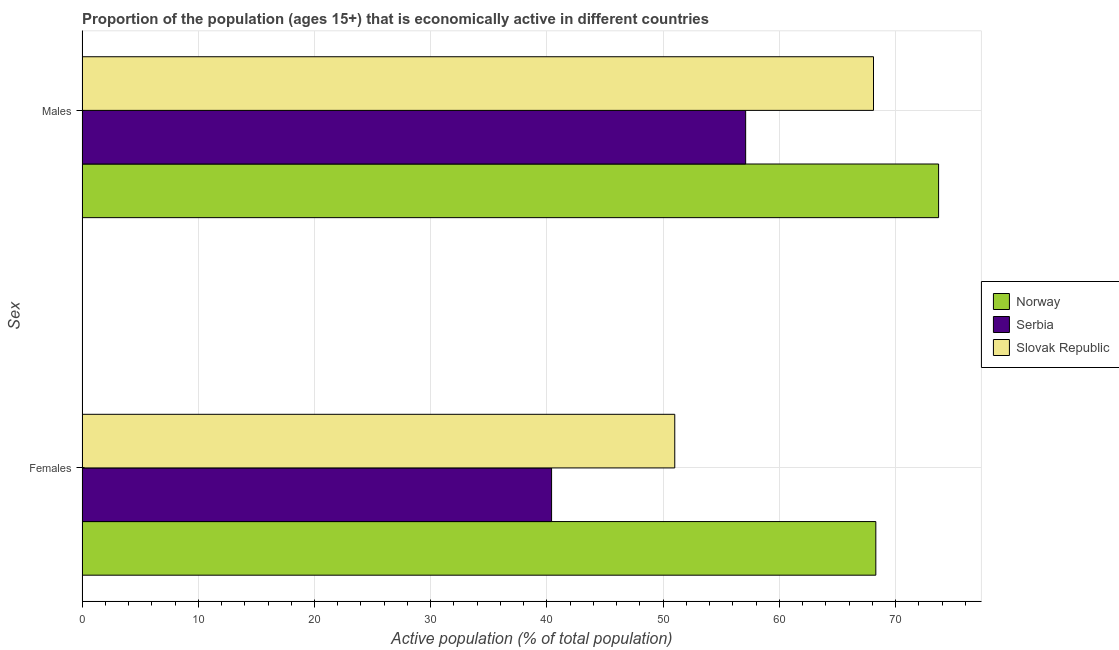Are the number of bars per tick equal to the number of legend labels?
Offer a very short reply. Yes. How many bars are there on the 1st tick from the top?
Provide a succinct answer. 3. How many bars are there on the 1st tick from the bottom?
Make the answer very short. 3. What is the label of the 2nd group of bars from the top?
Provide a succinct answer. Females. What is the percentage of economically active female population in Norway?
Keep it short and to the point. 68.3. Across all countries, what is the maximum percentage of economically active female population?
Offer a very short reply. 68.3. Across all countries, what is the minimum percentage of economically active male population?
Offer a very short reply. 57.1. In which country was the percentage of economically active male population maximum?
Ensure brevity in your answer.  Norway. In which country was the percentage of economically active female population minimum?
Ensure brevity in your answer.  Serbia. What is the total percentage of economically active male population in the graph?
Give a very brief answer. 198.9. What is the difference between the percentage of economically active female population in Slovak Republic and that in Norway?
Ensure brevity in your answer.  -17.3. What is the difference between the percentage of economically active male population in Norway and the percentage of economically active female population in Slovak Republic?
Offer a terse response. 22.7. What is the average percentage of economically active female population per country?
Provide a short and direct response. 53.23. What is the difference between the percentage of economically active male population and percentage of economically active female population in Serbia?
Keep it short and to the point. 16.7. In how many countries, is the percentage of economically active male population greater than 46 %?
Provide a short and direct response. 3. What is the ratio of the percentage of economically active male population in Serbia to that in Slovak Republic?
Offer a very short reply. 0.84. Is the percentage of economically active female population in Serbia less than that in Slovak Republic?
Ensure brevity in your answer.  Yes. What does the 2nd bar from the top in Males represents?
Ensure brevity in your answer.  Serbia. What does the 3rd bar from the bottom in Females represents?
Provide a short and direct response. Slovak Republic. What is the difference between two consecutive major ticks on the X-axis?
Offer a terse response. 10. Are the values on the major ticks of X-axis written in scientific E-notation?
Offer a terse response. No. How many legend labels are there?
Offer a terse response. 3. How are the legend labels stacked?
Provide a succinct answer. Vertical. What is the title of the graph?
Give a very brief answer. Proportion of the population (ages 15+) that is economically active in different countries. Does "Brazil" appear as one of the legend labels in the graph?
Offer a very short reply. No. What is the label or title of the X-axis?
Ensure brevity in your answer.  Active population (% of total population). What is the label or title of the Y-axis?
Your answer should be very brief. Sex. What is the Active population (% of total population) in Norway in Females?
Your answer should be compact. 68.3. What is the Active population (% of total population) in Serbia in Females?
Ensure brevity in your answer.  40.4. What is the Active population (% of total population) of Slovak Republic in Females?
Provide a succinct answer. 51. What is the Active population (% of total population) in Norway in Males?
Provide a short and direct response. 73.7. What is the Active population (% of total population) in Serbia in Males?
Your response must be concise. 57.1. What is the Active population (% of total population) in Slovak Republic in Males?
Provide a short and direct response. 68.1. Across all Sex, what is the maximum Active population (% of total population) in Norway?
Offer a very short reply. 73.7. Across all Sex, what is the maximum Active population (% of total population) in Serbia?
Offer a terse response. 57.1. Across all Sex, what is the maximum Active population (% of total population) in Slovak Republic?
Provide a short and direct response. 68.1. Across all Sex, what is the minimum Active population (% of total population) in Norway?
Your answer should be very brief. 68.3. Across all Sex, what is the minimum Active population (% of total population) of Serbia?
Offer a terse response. 40.4. Across all Sex, what is the minimum Active population (% of total population) in Slovak Republic?
Give a very brief answer. 51. What is the total Active population (% of total population) in Norway in the graph?
Your answer should be compact. 142. What is the total Active population (% of total population) in Serbia in the graph?
Your answer should be very brief. 97.5. What is the total Active population (% of total population) of Slovak Republic in the graph?
Provide a succinct answer. 119.1. What is the difference between the Active population (% of total population) in Norway in Females and that in Males?
Your response must be concise. -5.4. What is the difference between the Active population (% of total population) in Serbia in Females and that in Males?
Your answer should be very brief. -16.7. What is the difference between the Active population (% of total population) in Slovak Republic in Females and that in Males?
Offer a terse response. -17.1. What is the difference between the Active population (% of total population) of Norway in Females and the Active population (% of total population) of Slovak Republic in Males?
Keep it short and to the point. 0.2. What is the difference between the Active population (% of total population) in Serbia in Females and the Active population (% of total population) in Slovak Republic in Males?
Give a very brief answer. -27.7. What is the average Active population (% of total population) of Norway per Sex?
Provide a succinct answer. 71. What is the average Active population (% of total population) of Serbia per Sex?
Offer a very short reply. 48.75. What is the average Active population (% of total population) of Slovak Republic per Sex?
Provide a short and direct response. 59.55. What is the difference between the Active population (% of total population) of Norway and Active population (% of total population) of Serbia in Females?
Provide a succinct answer. 27.9. What is the difference between the Active population (% of total population) of Norway and Active population (% of total population) of Slovak Republic in Females?
Provide a short and direct response. 17.3. What is the difference between the Active population (% of total population) of Norway and Active population (% of total population) of Serbia in Males?
Your answer should be compact. 16.6. What is the difference between the Active population (% of total population) in Serbia and Active population (% of total population) in Slovak Republic in Males?
Provide a succinct answer. -11. What is the ratio of the Active population (% of total population) of Norway in Females to that in Males?
Offer a terse response. 0.93. What is the ratio of the Active population (% of total population) of Serbia in Females to that in Males?
Give a very brief answer. 0.71. What is the ratio of the Active population (% of total population) in Slovak Republic in Females to that in Males?
Provide a short and direct response. 0.75. What is the difference between the highest and the second highest Active population (% of total population) of Norway?
Your answer should be very brief. 5.4. What is the difference between the highest and the second highest Active population (% of total population) of Serbia?
Keep it short and to the point. 16.7. What is the difference between the highest and the second highest Active population (% of total population) of Slovak Republic?
Keep it short and to the point. 17.1. What is the difference between the highest and the lowest Active population (% of total population) of Norway?
Provide a short and direct response. 5.4. What is the difference between the highest and the lowest Active population (% of total population) of Serbia?
Offer a very short reply. 16.7. What is the difference between the highest and the lowest Active population (% of total population) in Slovak Republic?
Your response must be concise. 17.1. 